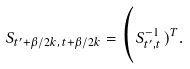<formula> <loc_0><loc_0><loc_500><loc_500>S _ { t ^ { \prime } + \beta / 2 k , \, t + \beta / 2 k } = \Big ( S _ { t ^ { \prime } , t \, } ^ { - 1 } ) ^ { T } .</formula> 